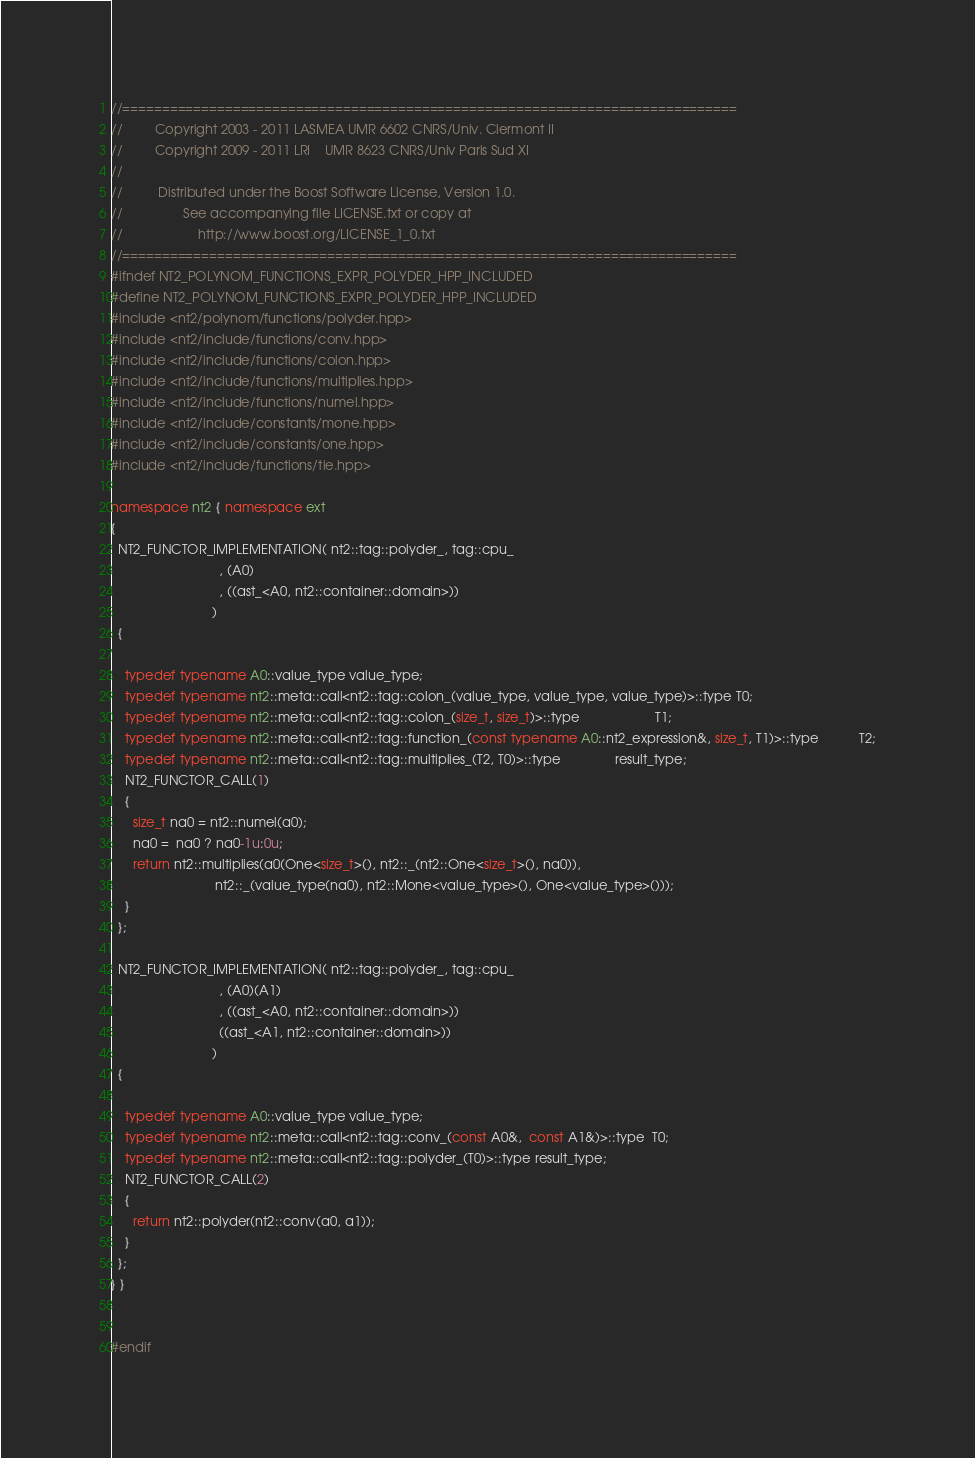Convert code to text. <code><loc_0><loc_0><loc_500><loc_500><_C++_>//==============================================================================
//         Copyright 2003 - 2011 LASMEA UMR 6602 CNRS/Univ. Clermont II
//         Copyright 2009 - 2011 LRI    UMR 8623 CNRS/Univ Paris Sud XI
//
//          Distributed under the Boost Software License, Version 1.0.
//                 See accompanying file LICENSE.txt or copy at
//                     http://www.boost.org/LICENSE_1_0.txt
//==============================================================================
#ifndef NT2_POLYNOM_FUNCTIONS_EXPR_POLYDER_HPP_INCLUDED
#define NT2_POLYNOM_FUNCTIONS_EXPR_POLYDER_HPP_INCLUDED
#include <nt2/polynom/functions/polyder.hpp>
#include <nt2/include/functions/conv.hpp>
#include <nt2/include/functions/colon.hpp>
#include <nt2/include/functions/multiplies.hpp>
#include <nt2/include/functions/numel.hpp>
#include <nt2/include/constants/mone.hpp>
#include <nt2/include/constants/one.hpp>
#include <nt2/include/functions/tie.hpp>

namespace nt2 { namespace ext
{
  NT2_FUNCTOR_IMPLEMENTATION( nt2::tag::polyder_, tag::cpu_
                              , (A0)
                              , ((ast_<A0, nt2::container::domain>))
                            )
  {

    typedef typename A0::value_type value_type;
    typedef typename nt2::meta::call<nt2::tag::colon_(value_type, value_type, value_type)>::type T0;
    typedef typename nt2::meta::call<nt2::tag::colon_(size_t, size_t)>::type                     T1;
    typedef typename nt2::meta::call<nt2::tag::function_(const typename A0::nt2_expression&, size_t, T1)>::type           T2;
    typedef typename nt2::meta::call<nt2::tag::multiplies_(T2, T0)>::type               result_type;
    NT2_FUNCTOR_CALL(1)
    {
      size_t na0 = nt2::numel(a0);
      na0 =  na0 ? na0-1u:0u;
      return nt2::multiplies(a0(One<size_t>(), nt2::_(nt2::One<size_t>(), na0)),
                             nt2::_(value_type(na0), nt2::Mone<value_type>(), One<value_type>()));
    }
  };

  NT2_FUNCTOR_IMPLEMENTATION( nt2::tag::polyder_, tag::cpu_
                              , (A0)(A1)
                              , ((ast_<A0, nt2::container::domain>))
                              ((ast_<A1, nt2::container::domain>))
                            )
  {

    typedef typename A0::value_type value_type;
    typedef typename nt2::meta::call<nt2::tag::conv_(const A0&,  const A1&)>::type  T0;
    typedef typename nt2::meta::call<nt2::tag::polyder_(T0)>::type result_type;
    NT2_FUNCTOR_CALL(2)
    {
      return nt2::polyder(nt2::conv(a0, a1));
    }
  };
} }


#endif
</code> 